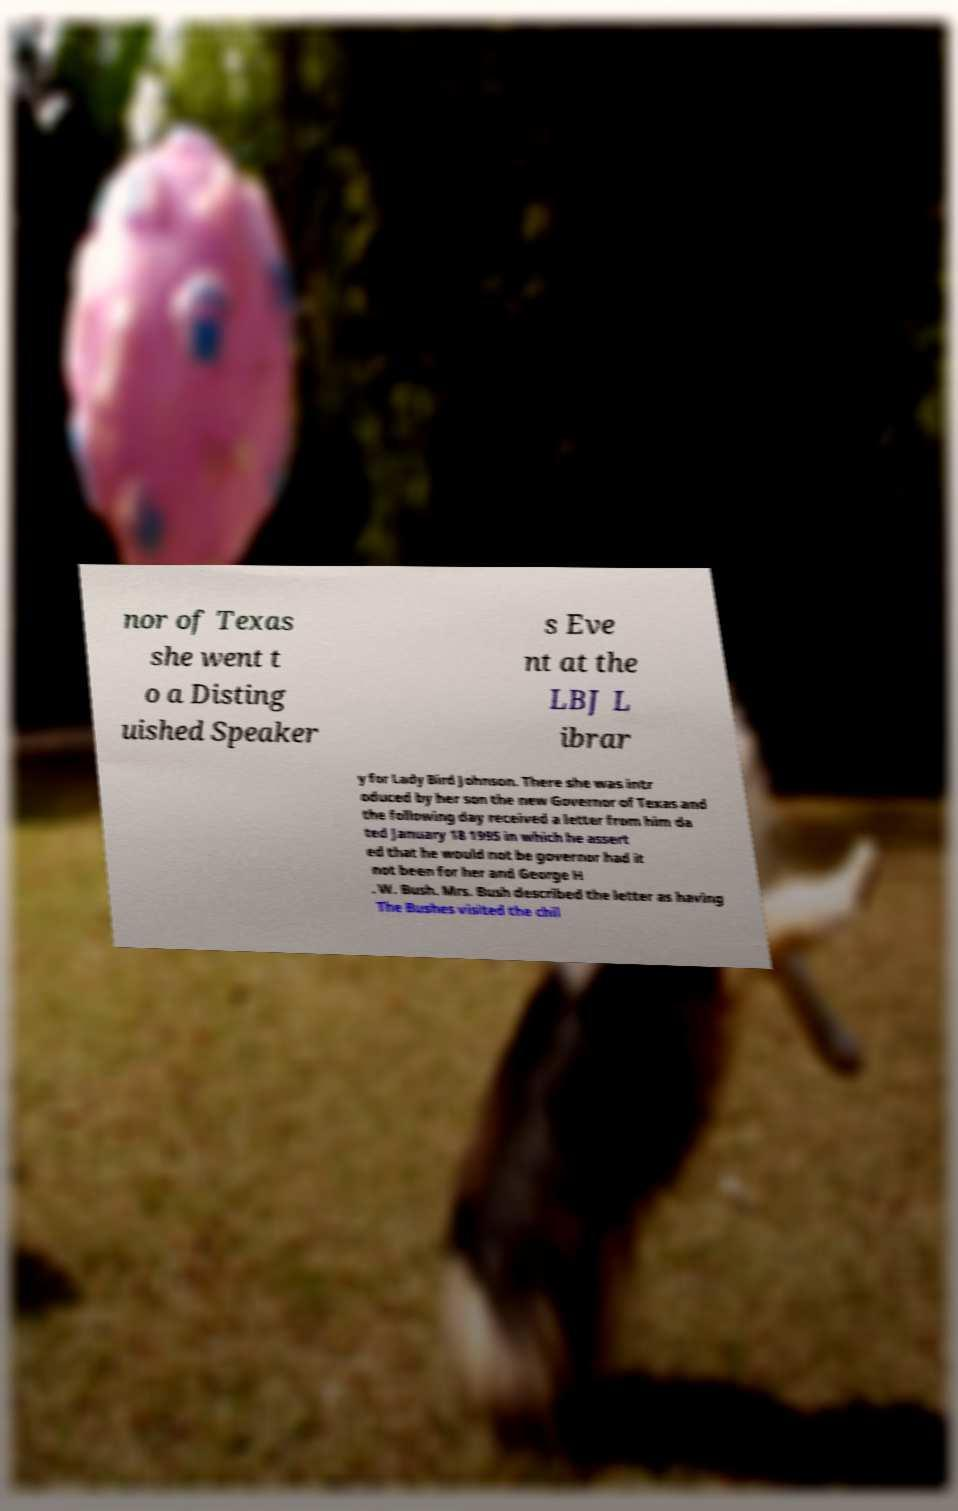Please read and relay the text visible in this image. What does it say? nor of Texas she went t o a Disting uished Speaker s Eve nt at the LBJ L ibrar y for Lady Bird Johnson. There she was intr oduced by her son the new Governor of Texas and the following day received a letter from him da ted January 18 1995 in which he assert ed that he would not be governor had it not been for her and George H . W. Bush. Mrs. Bush described the letter as having The Bushes visited the chil 